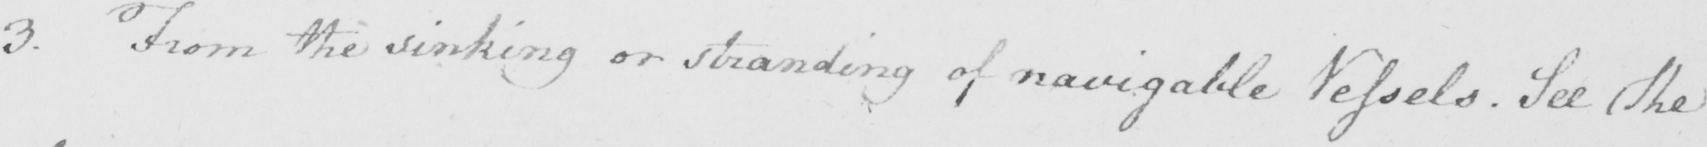Can you tell me what this handwritten text says? 3 . From the sinking or stranding of navigable Vessels . See the 